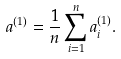<formula> <loc_0><loc_0><loc_500><loc_500>a ^ { ( 1 ) } = \frac { 1 } { n } \sum _ { i = 1 } ^ { n } a _ { i } ^ { ( 1 ) } .</formula> 